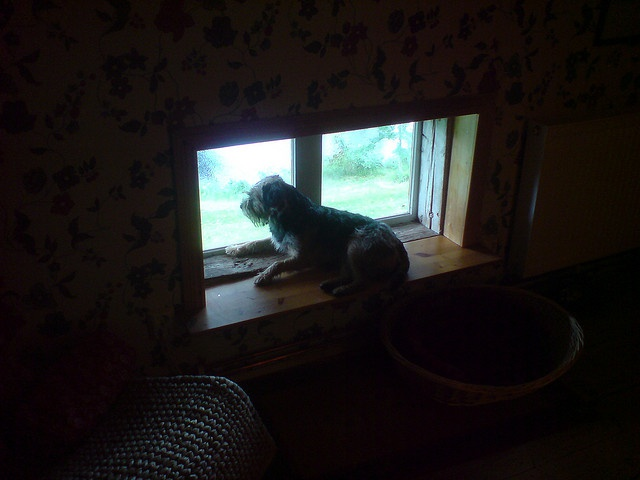Describe the objects in this image and their specific colors. I can see bowl in black tones, chair in black and teal tones, and dog in black, teal, gray, and darkblue tones in this image. 